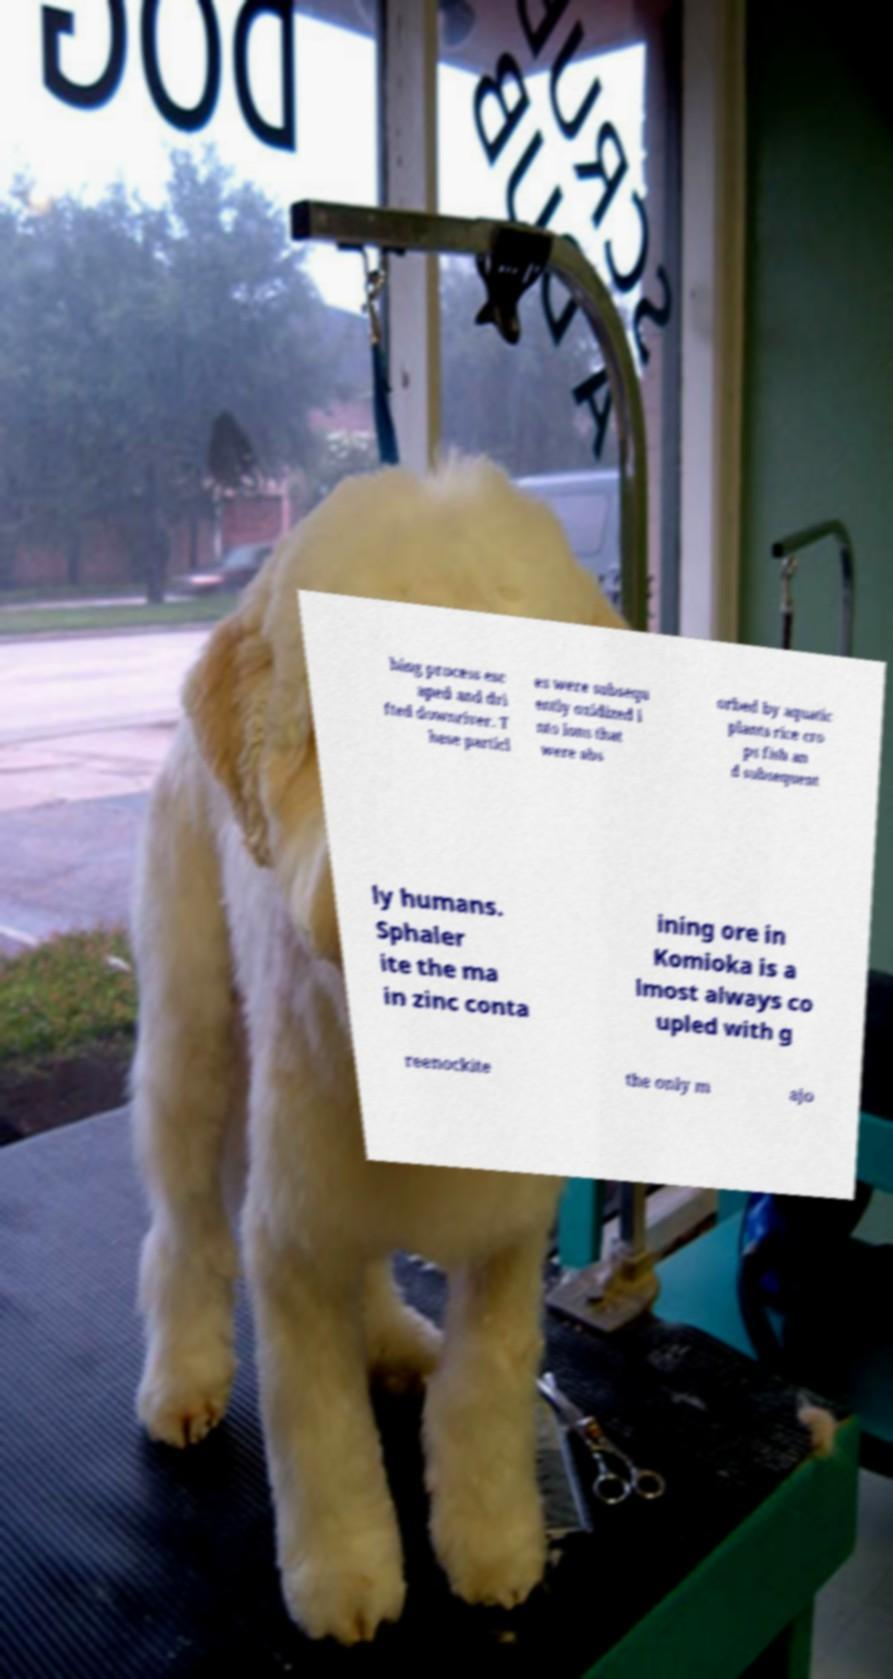I need the written content from this picture converted into text. Can you do that? hing process esc aped and dri fted downriver. T hese particl es were subsequ ently oxidized i nto ions that were abs orbed by aquatic plants rice cro ps fish an d subsequent ly humans. Sphaler ite the ma in zinc conta ining ore in Komioka is a lmost always co upled with g reenockite the only m ajo 